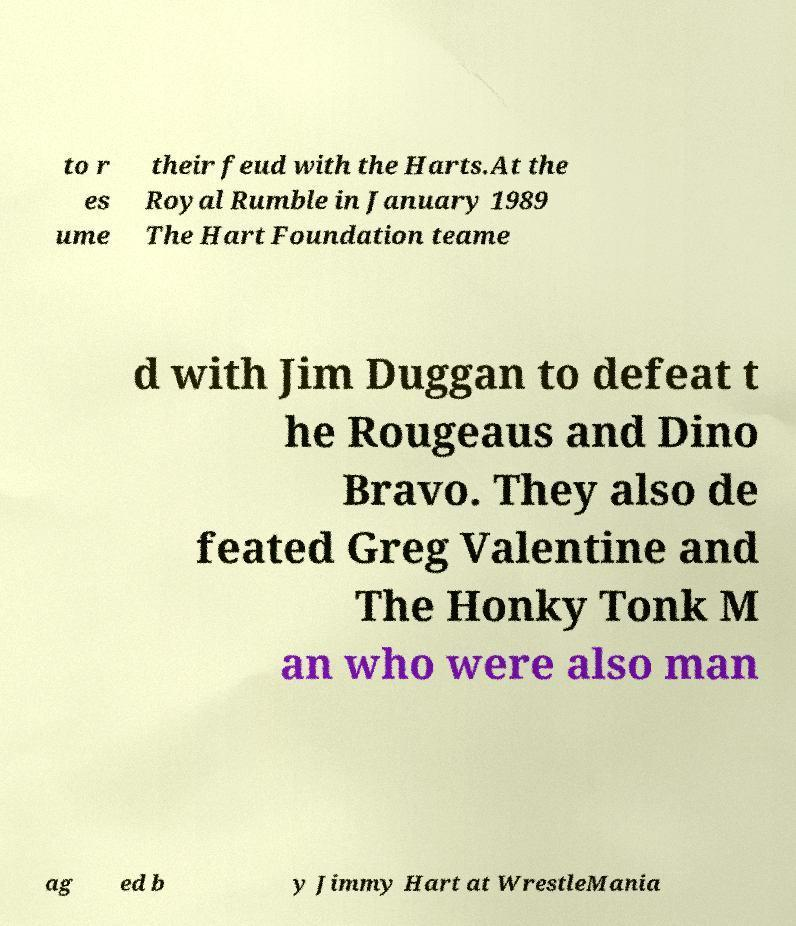What messages or text are displayed in this image? I need them in a readable, typed format. to r es ume their feud with the Harts.At the Royal Rumble in January 1989 The Hart Foundation teame d with Jim Duggan to defeat t he Rougeaus and Dino Bravo. They also de feated Greg Valentine and The Honky Tonk M an who were also man ag ed b y Jimmy Hart at WrestleMania 